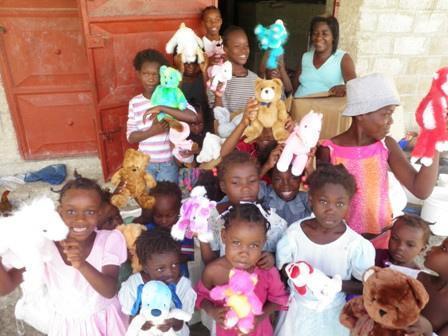How many children are holding blue stuffed animals?
Give a very brief answer. 3. 